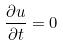<formula> <loc_0><loc_0><loc_500><loc_500>\frac { \partial u } { \partial t } = 0</formula> 